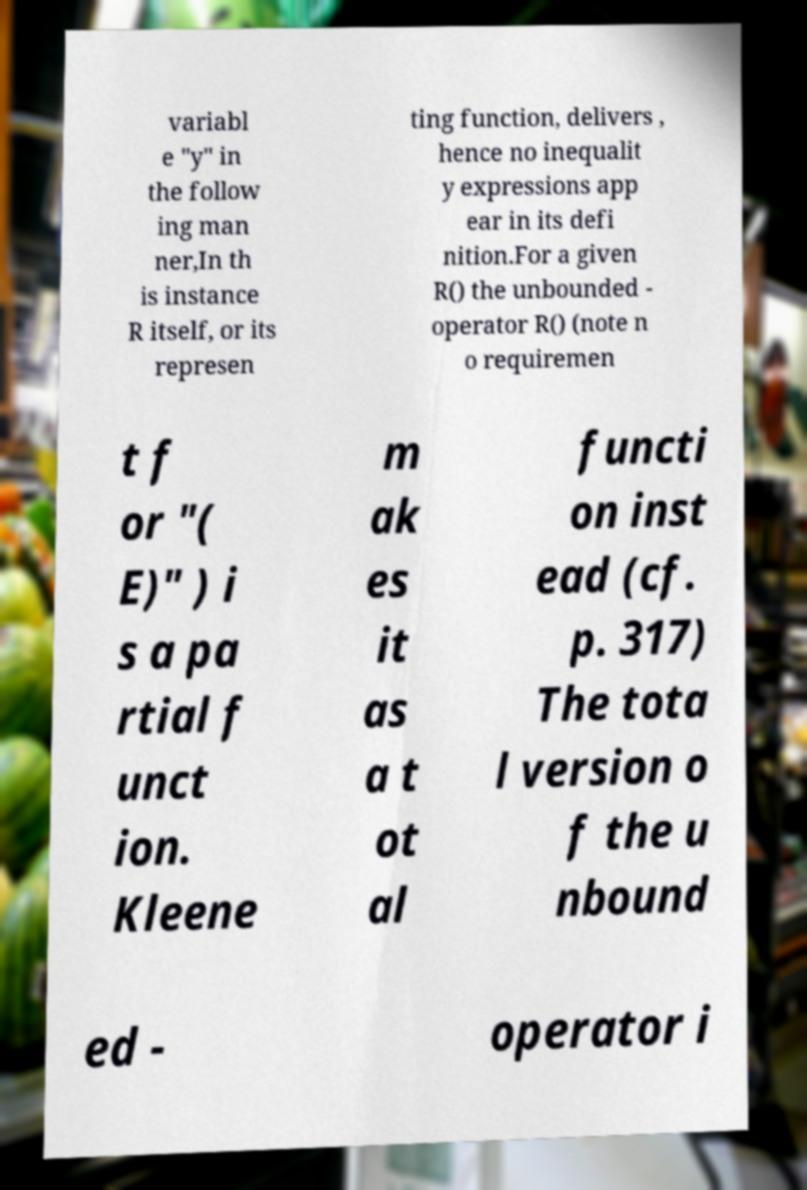Please identify and transcribe the text found in this image. variabl e "y" in the follow ing man ner,In th is instance R itself, or its represen ting function, delivers , hence no inequalit y expressions app ear in its defi nition.For a given R() the unbounded - operator R() (note n o requiremen t f or "( E)" ) i s a pa rtial f unct ion. Kleene m ak es it as a t ot al functi on inst ead (cf. p. 317) The tota l version o f the u nbound ed - operator i 